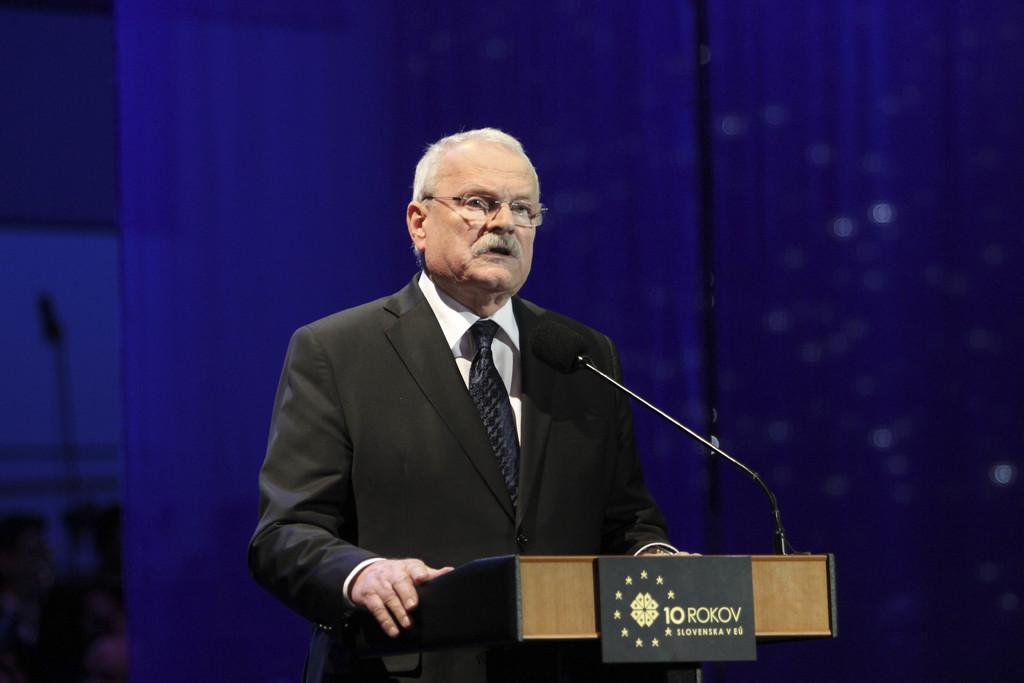What is the man in the image wearing? The man in the image is wearing a suit. What accessory is the man wearing on his face? The man is wearing spectacles. What is in front of the man in the image? There is a podium in front of the man. What is on the podium? There is a microphone and a board on the podium. What can be seen in the background of the image? The background of the image is blurry, and blue curtains are visible. What type of nail is being hammered into the roof in the image? There is no nail or roof present in the image; it features a man standing at a podium with a microphone and a board. 